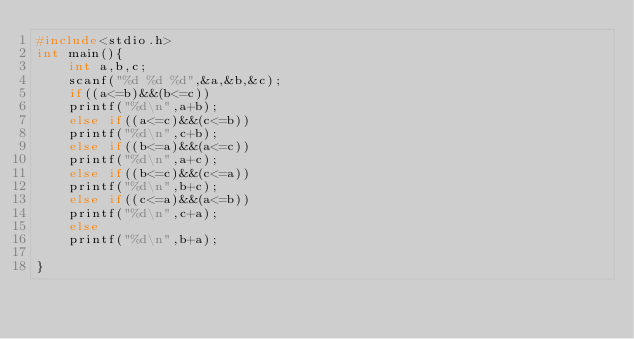<code> <loc_0><loc_0><loc_500><loc_500><_C_>#include<stdio.h>
int main(){
    int a,b,c;
    scanf("%d %d %d",&a,&b,&c);
    if((a<=b)&&(b<=c))
    printf("%d\n",a+b);
    else if((a<=c)&&(c<=b))
    printf("%d\n",c+b);
    else if((b<=a)&&(a<=c))
    printf("%d\n",a+c);
    else if((b<=c)&&(c<=a))
    printf("%d\n",b+c);
    else if((c<=a)&&(a<=b))
    printf("%d\n",c+a);
    else
    printf("%d\n",b+a);
    
}</code> 